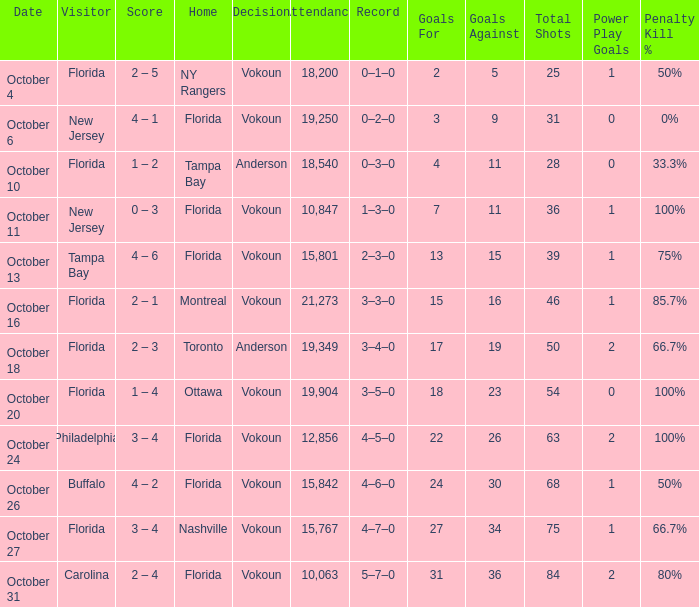Which team was home on October 13? Florida. 